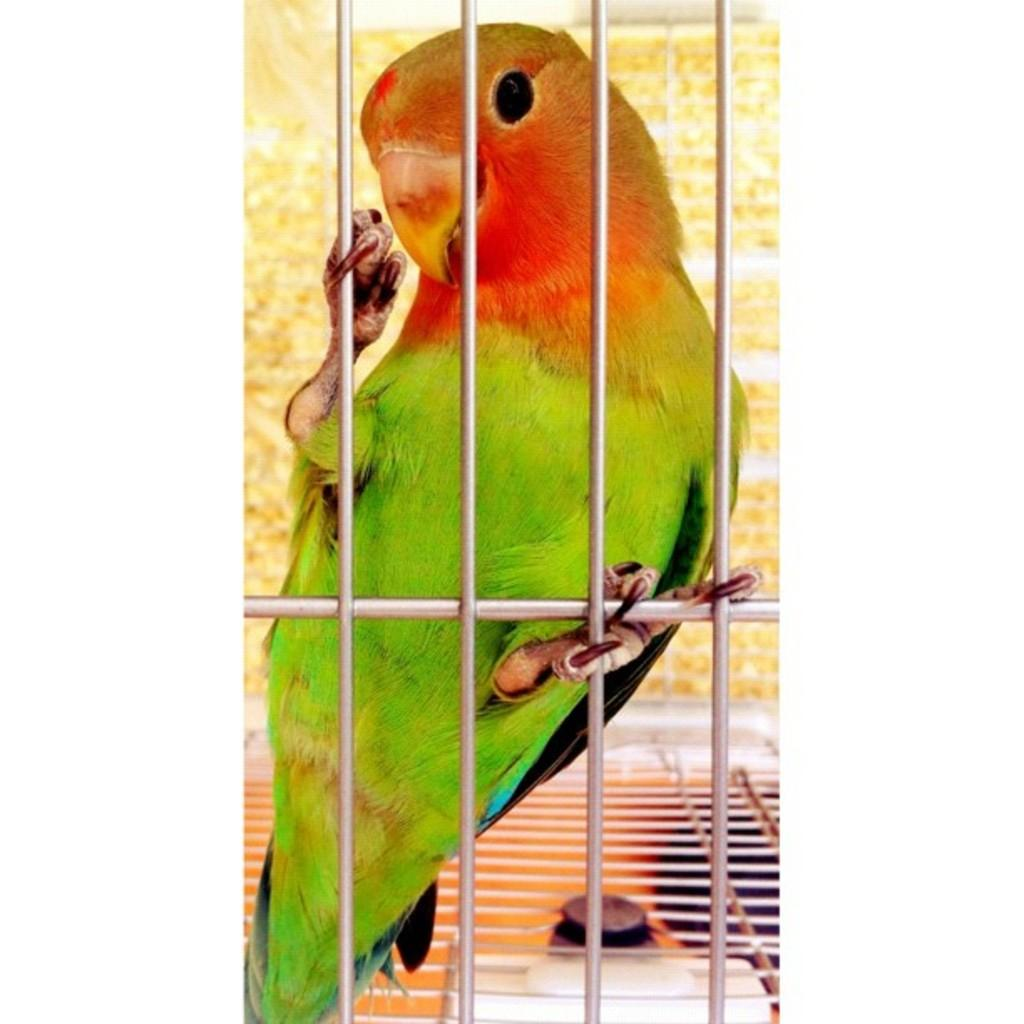What type of animal is in the image? There is a parrot in the image. Where is the parrot located? The parrot is inside a cage. What type of surprise is the parrot holding in its beak in the image? There is no surprise visible in the image; the parrot is not holding anything in its beak. 